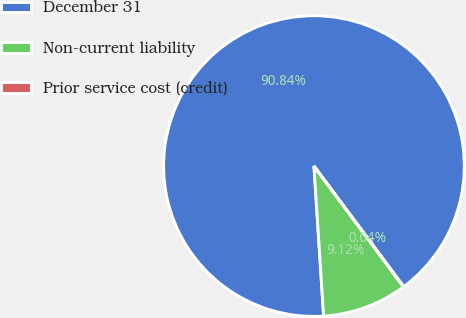Convert chart. <chart><loc_0><loc_0><loc_500><loc_500><pie_chart><fcel>December 31<fcel>Non-current liability<fcel>Prior service cost (credit)<nl><fcel>90.85%<fcel>9.12%<fcel>0.04%<nl></chart> 